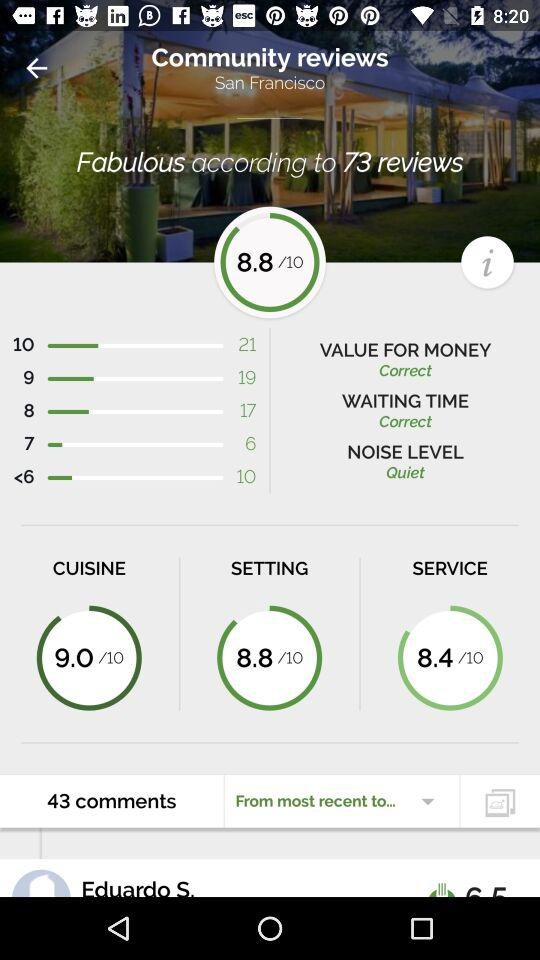Which category has a rating of 8.8 out of 10? The category "SETTING" has a rating of 8.8 out of 10. 